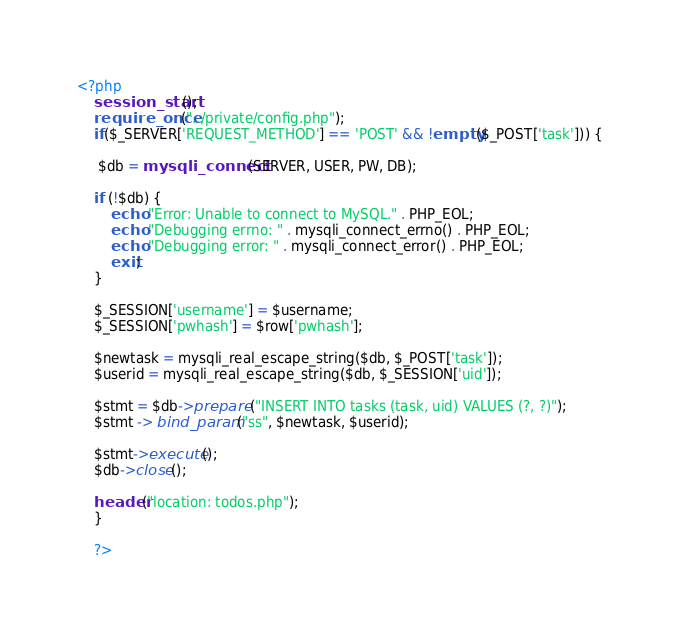<code> <loc_0><loc_0><loc_500><loc_500><_PHP_><?php
    session_start();
    require_once("../private/config.php");
    if($_SERVER['REQUEST_METHOD'] == 'POST' && !empty($_POST['task'])) {

     $db = mysqli_connect(SERVER, USER, PW, DB);

    if (!$db) {
        echo "Error: Unable to connect to MySQL." . PHP_EOL;
        echo "Debugging errno: " . mysqli_connect_errno() . PHP_EOL;
        echo "Debugging error: " . mysqli_connect_error() . PHP_EOL;
        exit;
    }
    
    $_SESSION['username'] = $username;
    $_SESSION['pwhash'] = $row['pwhash'];
    
    $newtask = mysqli_real_escape_string($db, $_POST['task']);
    $userid = mysqli_real_escape_string($db, $_SESSION['uid']);

    $stmt = $db->prepare ("INSERT INTO tasks (task, uid) VALUES (?, ?)");
    $stmt -> bind_param("ss", $newtask, $userid);
        
    $stmt->execute();
    $db->close();
        
    header("location: todos.php");
    }

    ?>
</code> 